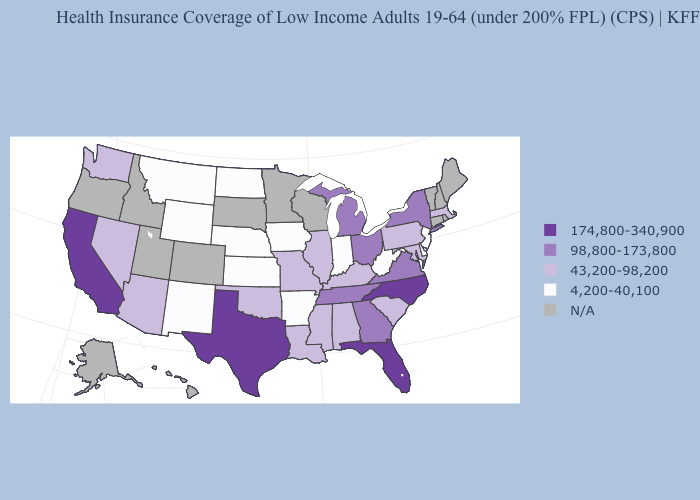What is the value of Idaho?
Give a very brief answer. N/A. Does the first symbol in the legend represent the smallest category?
Keep it brief. No. Among the states that border Nebraska , which have the lowest value?
Answer briefly. Iowa, Kansas, Wyoming. Does the map have missing data?
Give a very brief answer. Yes. Does New Jersey have the lowest value in the Northeast?
Be succinct. Yes. Is the legend a continuous bar?
Concise answer only. No. What is the lowest value in the USA?
Be succinct. 4,200-40,100. What is the highest value in the West ?
Answer briefly. 174,800-340,900. Name the states that have a value in the range 98,800-173,800?
Quick response, please. Georgia, Michigan, New York, Ohio, Tennessee, Virginia. Does the map have missing data?
Be succinct. Yes. What is the value of Ohio?
Answer briefly. 98,800-173,800. Among the states that border Iowa , which have the lowest value?
Quick response, please. Nebraska. Among the states that border Florida , which have the lowest value?
Concise answer only. Alabama. 